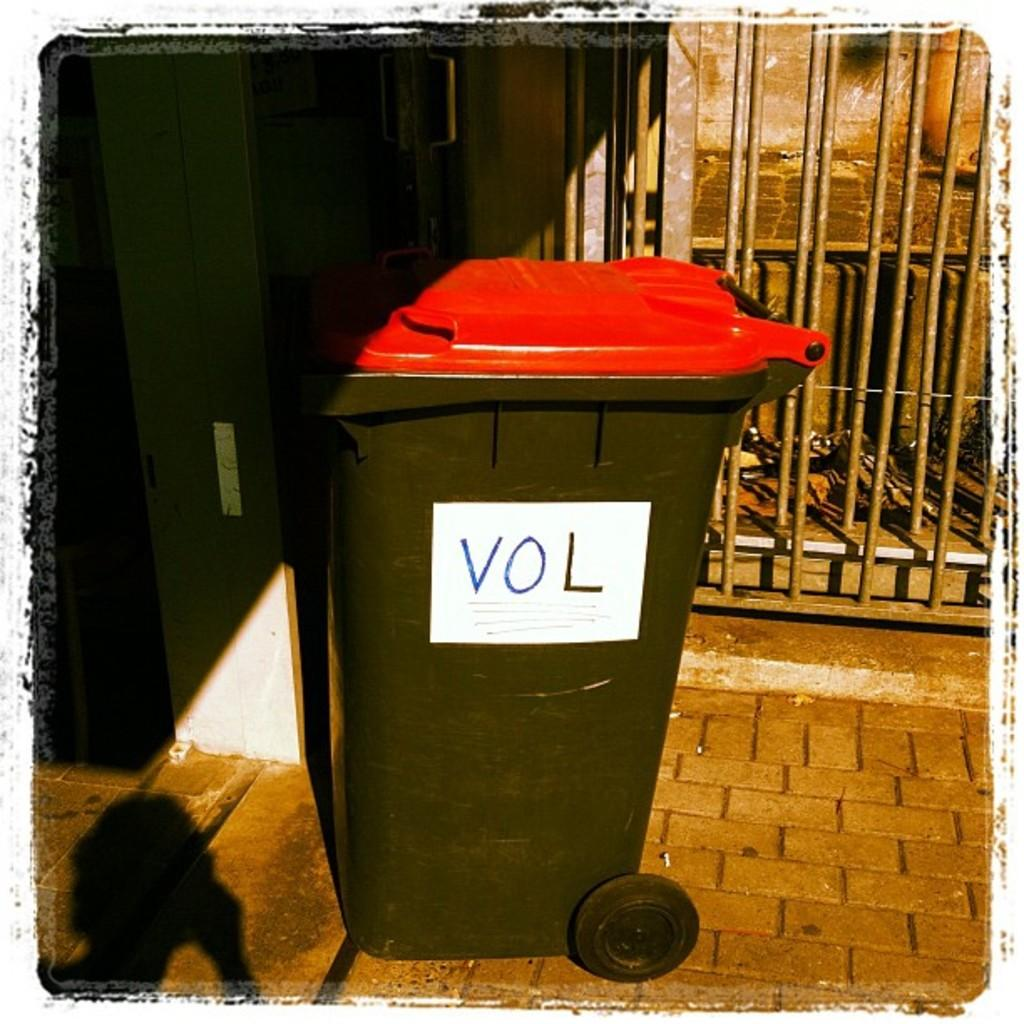<image>
Write a terse but informative summary of the picture. A red and black trash can with the letters VOL on it. 